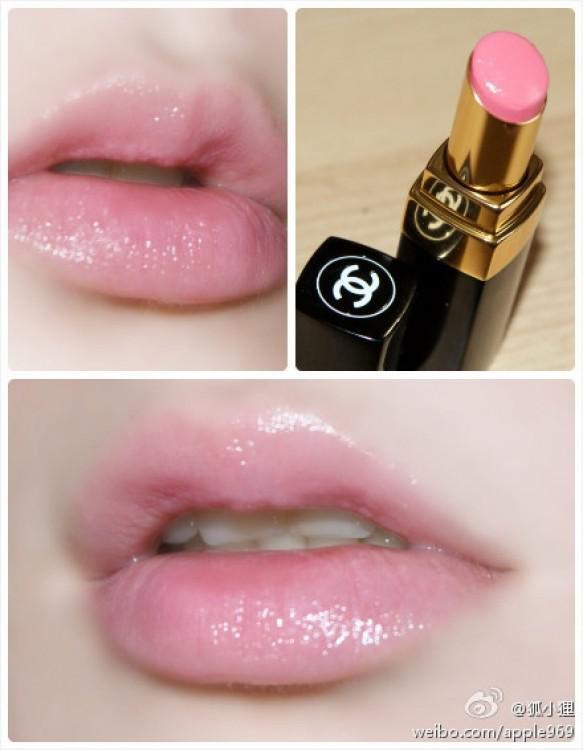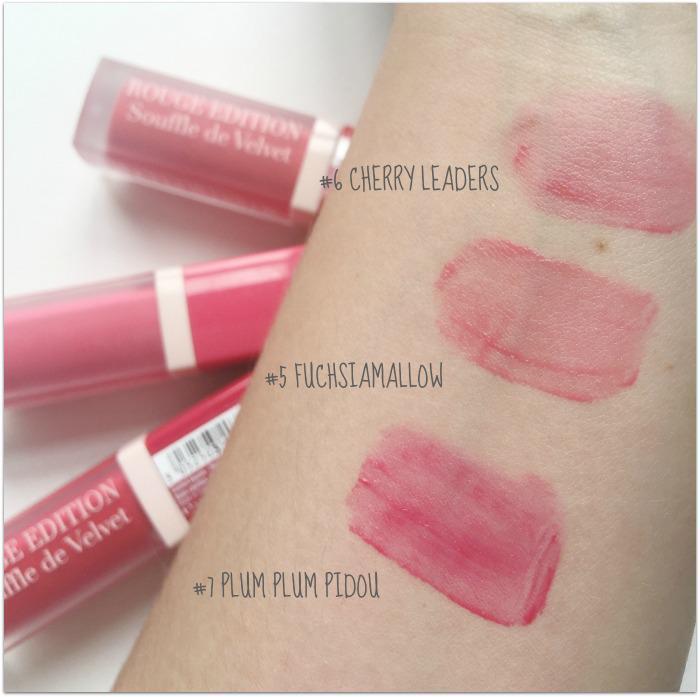The first image is the image on the left, the second image is the image on the right. Considering the images on both sides, is "At least two pairs of lips are visible." valid? Answer yes or no. Yes. The first image is the image on the left, the second image is the image on the right. Given the left and right images, does the statement "There are lips in one of the images." hold true? Answer yes or no. Yes. 